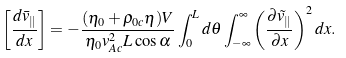<formula> <loc_0><loc_0><loc_500><loc_500>\left [ \frac { d \bar { v } _ { \| } } { d x } \right ] = - \frac { ( \eta _ { 0 } + \rho _ { 0 c } \eta ) V } { \eta _ { 0 } v _ { A c } ^ { 2 } L \cos \alpha } \int _ { 0 } ^ { L } d \theta \int _ { - \infty } ^ { \infty } \left ( \frac { \partial \tilde { v } _ { \| } } { \partial x } \right ) ^ { 2 } d x .</formula> 